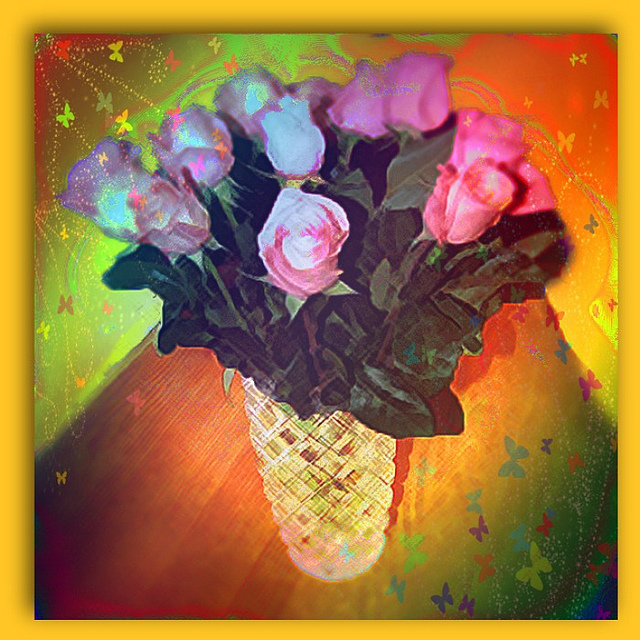What might this image say about the culture or era it represents? While the image itself doesn't provide direct clues about a specific culture or era, the use of rich, saturated colors and digital manipulation techniques suggest a modern, perhaps 21st-century approach to art. The playfulness and freedom of expression indicated by the abstract style could speak to contemporary values of creativity and individualism. What celebrations might use such vibrant floral imagery? Floral imagery this vibrant could be associated with various celebrations, including spring festivals, birthdays, or cultural events like the Indian festival of Holi, which celebrates the arrival of spring with an abundance of color. It might also be used in contexts like art installations or themed parties that aim to create a joyous and lively atmosphere. 